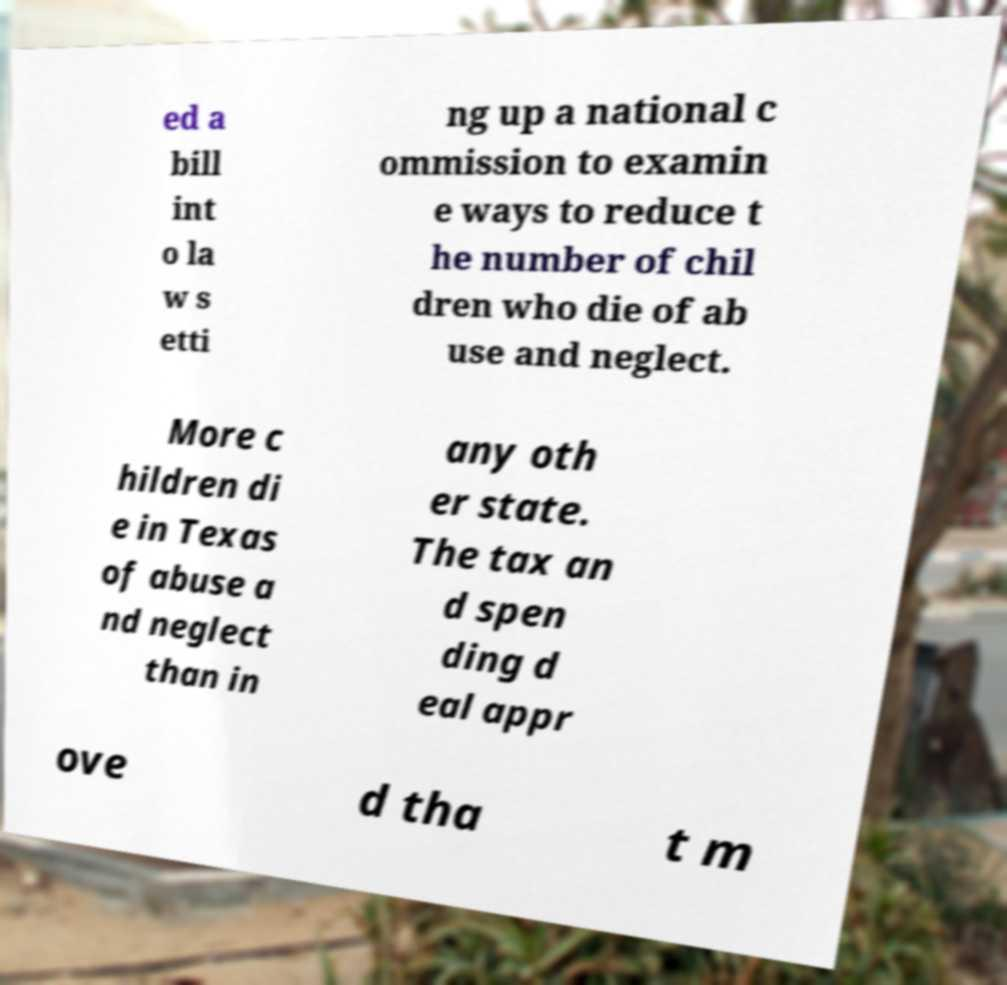Can you read and provide the text displayed in the image?This photo seems to have some interesting text. Can you extract and type it out for me? ed a bill int o la w s etti ng up a national c ommission to examin e ways to reduce t he number of chil dren who die of ab use and neglect. More c hildren di e in Texas of abuse a nd neglect than in any oth er state. The tax an d spen ding d eal appr ove d tha t m 